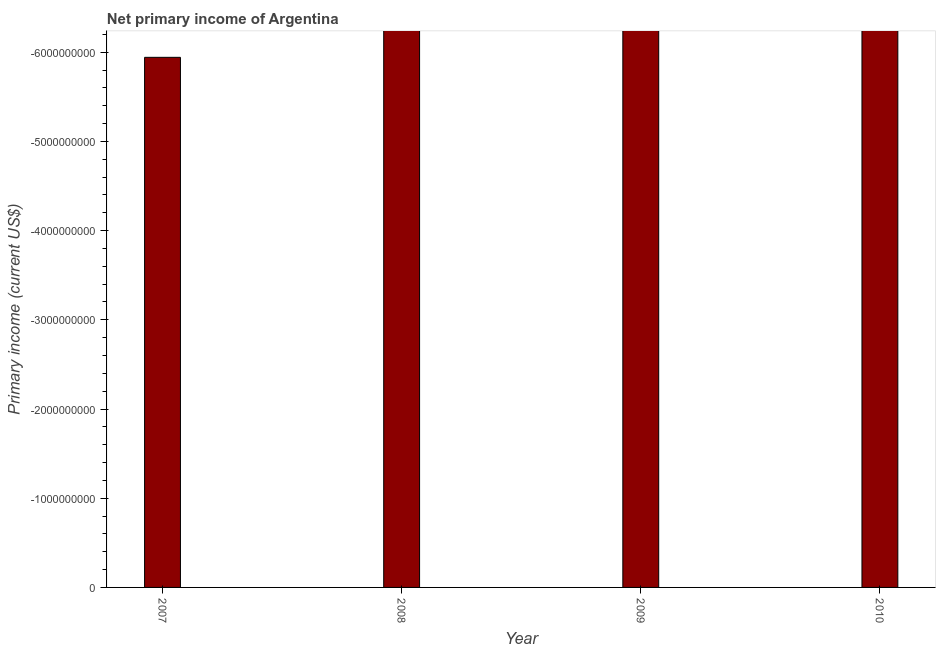Does the graph contain any zero values?
Offer a very short reply. Yes. Does the graph contain grids?
Keep it short and to the point. No. What is the title of the graph?
Keep it short and to the point. Net primary income of Argentina. What is the label or title of the X-axis?
Offer a very short reply. Year. What is the label or title of the Y-axis?
Offer a terse response. Primary income (current US$). Across all years, what is the minimum amount of primary income?
Your response must be concise. 0. What is the sum of the amount of primary income?
Ensure brevity in your answer.  0. What is the median amount of primary income?
Give a very brief answer. 0. In how many years, is the amount of primary income greater than the average amount of primary income taken over all years?
Provide a short and direct response. 0. How many bars are there?
Keep it short and to the point. 0. Are all the bars in the graph horizontal?
Your answer should be compact. No. What is the Primary income (current US$) of 2009?
Your response must be concise. 0. 